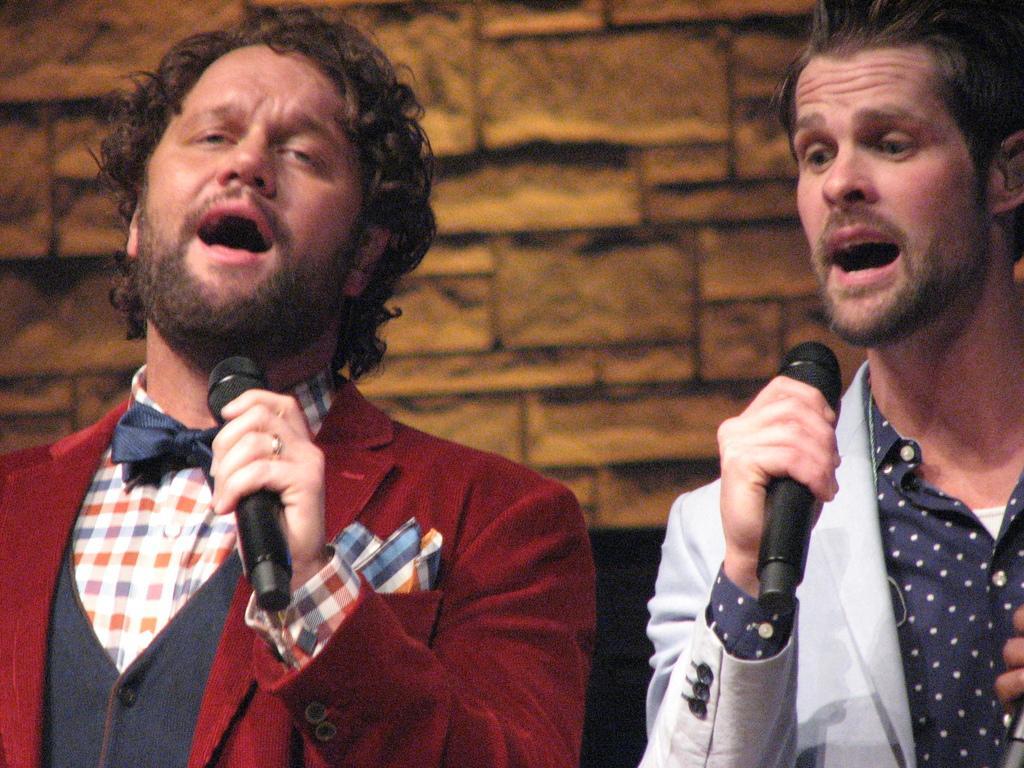Could you give a brief overview of what you see in this image? In this image, There are two mans standing and holding the microphones which are in black color and they are singing, In the background there is a yellow color wall. 